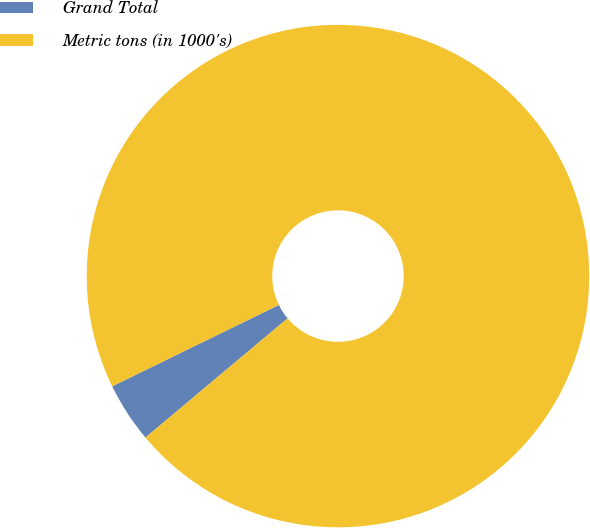<chart> <loc_0><loc_0><loc_500><loc_500><pie_chart><fcel>Grand Total<fcel>Metric tons (in 1000's)<nl><fcel>3.88%<fcel>96.12%<nl></chart> 